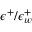<formula> <loc_0><loc_0><loc_500><loc_500>\epsilon ^ { + } / \epsilon _ { w } ^ { + }</formula> 